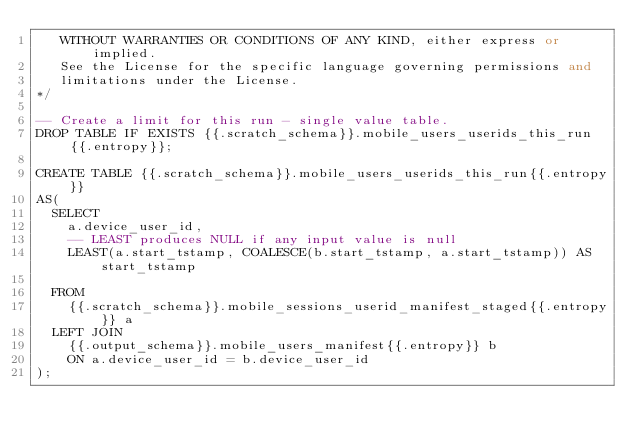<code> <loc_0><loc_0><loc_500><loc_500><_SQL_>   WITHOUT WARRANTIES OR CONDITIONS OF ANY KIND, either express or implied.
   See the License for the specific language governing permissions and
   limitations under the License.
*/

-- Create a limit for this run - single value table.
DROP TABLE IF EXISTS {{.scratch_schema}}.mobile_users_userids_this_run{{.entropy}};

CREATE TABLE {{.scratch_schema}}.mobile_users_userids_this_run{{.entropy}}
AS(
  SELECT
    a.device_user_id,
    -- LEAST produces NULL if any input value is null
    LEAST(a.start_tstamp, COALESCE(b.start_tstamp, a.start_tstamp)) AS start_tstamp

  FROM
    {{.scratch_schema}}.mobile_sessions_userid_manifest_staged{{.entropy}} a
  LEFT JOIN
    {{.output_schema}}.mobile_users_manifest{{.entropy}} b
    ON a.device_user_id = b.device_user_id
);
</code> 